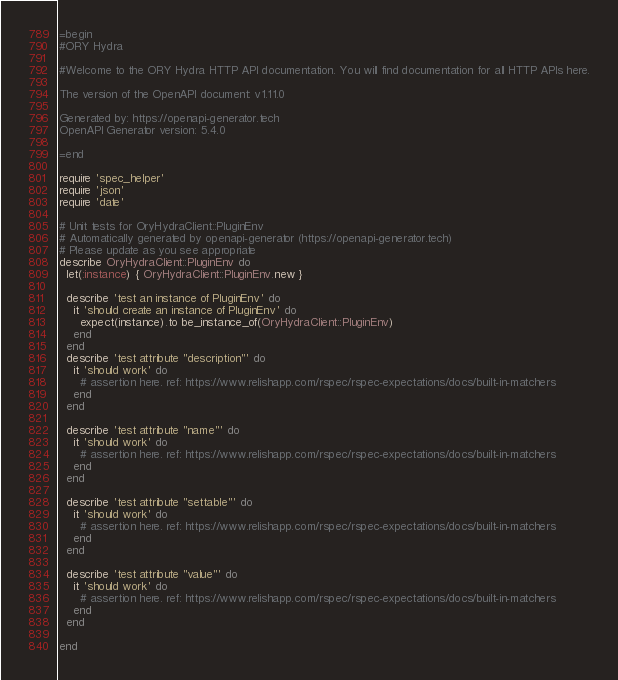Convert code to text. <code><loc_0><loc_0><loc_500><loc_500><_Ruby_>=begin
#ORY Hydra

#Welcome to the ORY Hydra HTTP API documentation. You will find documentation for all HTTP APIs here.

The version of the OpenAPI document: v1.11.0

Generated by: https://openapi-generator.tech
OpenAPI Generator version: 5.4.0

=end

require 'spec_helper'
require 'json'
require 'date'

# Unit tests for OryHydraClient::PluginEnv
# Automatically generated by openapi-generator (https://openapi-generator.tech)
# Please update as you see appropriate
describe OryHydraClient::PluginEnv do
  let(:instance) { OryHydraClient::PluginEnv.new }

  describe 'test an instance of PluginEnv' do
    it 'should create an instance of PluginEnv' do
      expect(instance).to be_instance_of(OryHydraClient::PluginEnv)
    end
  end
  describe 'test attribute "description"' do
    it 'should work' do
      # assertion here. ref: https://www.relishapp.com/rspec/rspec-expectations/docs/built-in-matchers
    end
  end

  describe 'test attribute "name"' do
    it 'should work' do
      # assertion here. ref: https://www.relishapp.com/rspec/rspec-expectations/docs/built-in-matchers
    end
  end

  describe 'test attribute "settable"' do
    it 'should work' do
      # assertion here. ref: https://www.relishapp.com/rspec/rspec-expectations/docs/built-in-matchers
    end
  end

  describe 'test attribute "value"' do
    it 'should work' do
      # assertion here. ref: https://www.relishapp.com/rspec/rspec-expectations/docs/built-in-matchers
    end
  end

end
</code> 